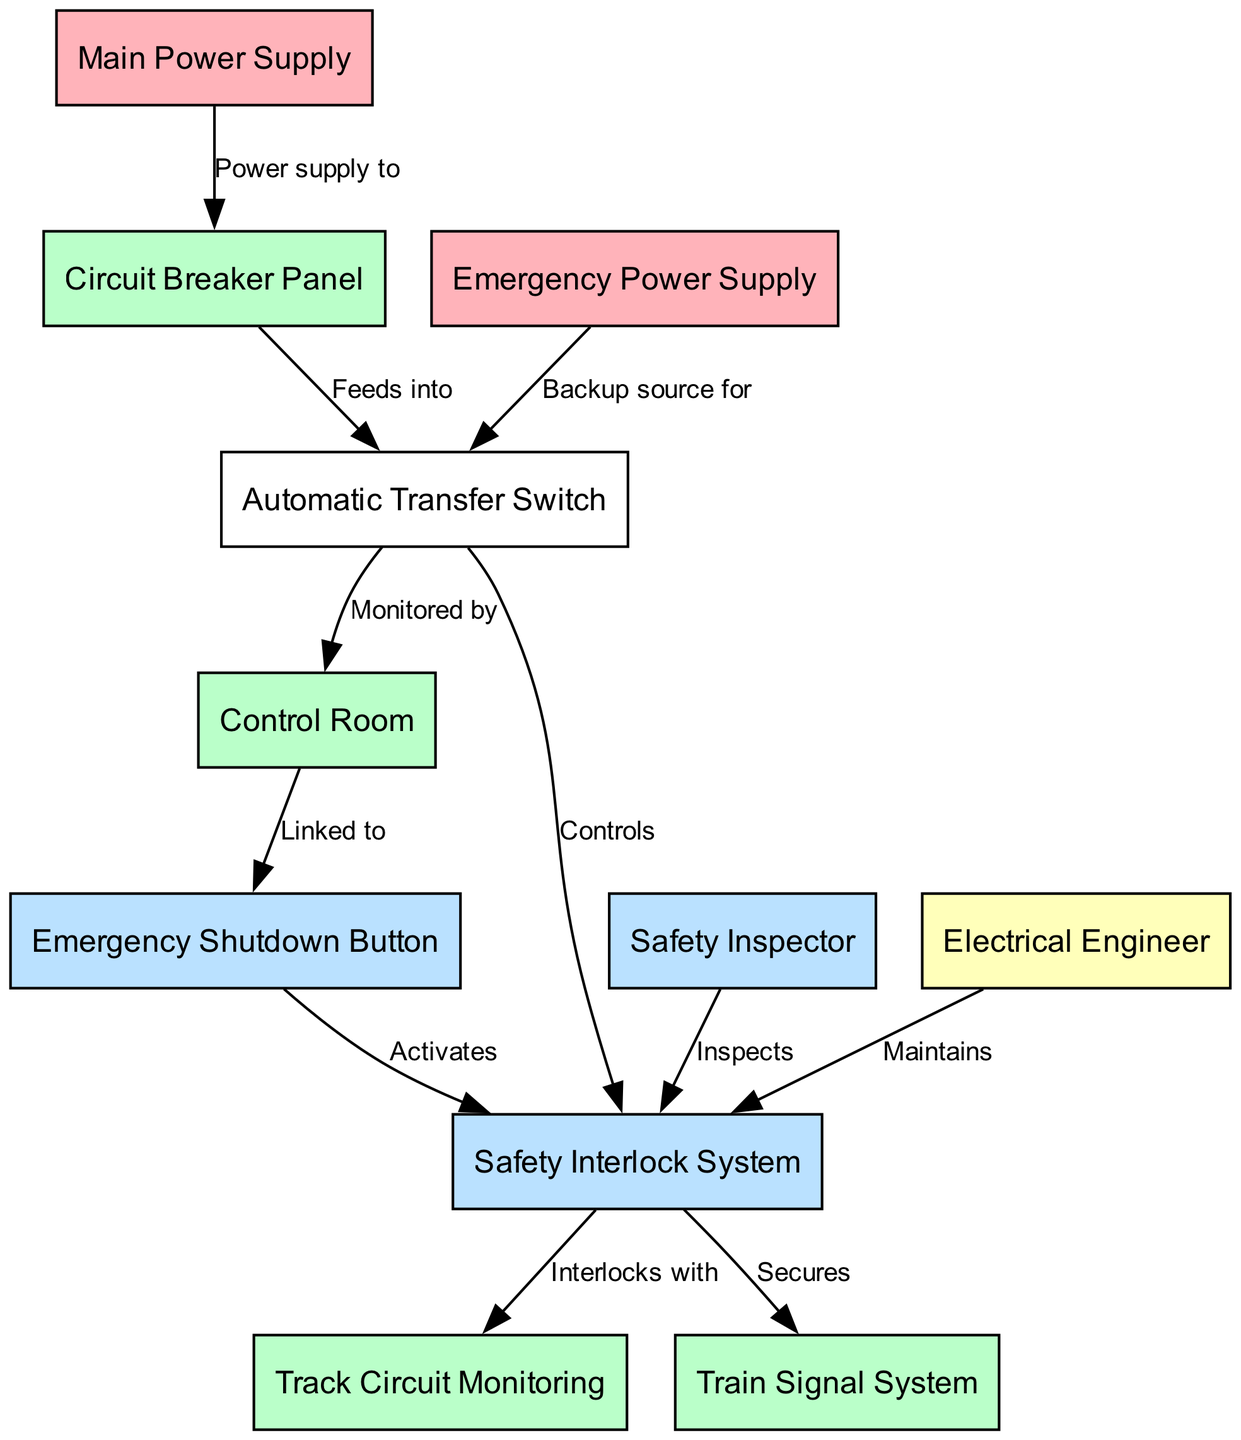What node does the Main Power Supply connect to? The Main Power Supply node connects to the Circuit Breaker Panel, as indicated by the edge labeled "Power supply to."
Answer: Circuit Breaker Panel How many nodes are present in the diagram? By counting the nodes listed in the data, there are a total of eleven nodes that represent various components in the system.
Answer: Eleven What is the role of the Emergency Power Supply? The Emergency Power Supply serves as a backup source for the Automatic Transfer Switch, providing power when the main source is unavailable, as shown by the labeled edge.
Answer: Backup source for Automatic Transfer Switch What does the Emergency Shutdown Button do? The Emergency Shutdown Button is linked to the Control Room and activates the Safety Interlock System when pressed, demonstrating its role in emergency procedures.
Answer: Activates Safety Interlock System Which two parties inspect and maintain the Safety Interlock System? The Safety Inspector inspects it, while the Electrical Engineer maintains it, indicating a collaborative approach to ensuring system safety.
Answer: Safety Inspector and Electrical Engineer What does the Safety Interlock System secure? The Safety Interlock System secures the Train Signal System, highlighting its importance in preventing accidents and ensuring safe railway operation.
Answer: Train Signal System What type of system is linked to the Control Room? The Control Room is linked to the Emergency Shutdown Button, which indicates that this button is part of the control mechanisms in place for managing emergencies.
Answer: Emergency Shutdown Button What components interlock with the Safety Interlock System? The Safety Interlock System interlocks with the Track Circuit Monitoring system, showing how these components work together to enhance safety on the railway.
Answer: Track Circuit Monitoring How does the Automatic Transfer Switch relate to the Control Room? The Automatic Transfer Switch feeds into the Control Room, which allows the control processes to monitor power supply and switching effectively.
Answer: Monitored by Control Room 